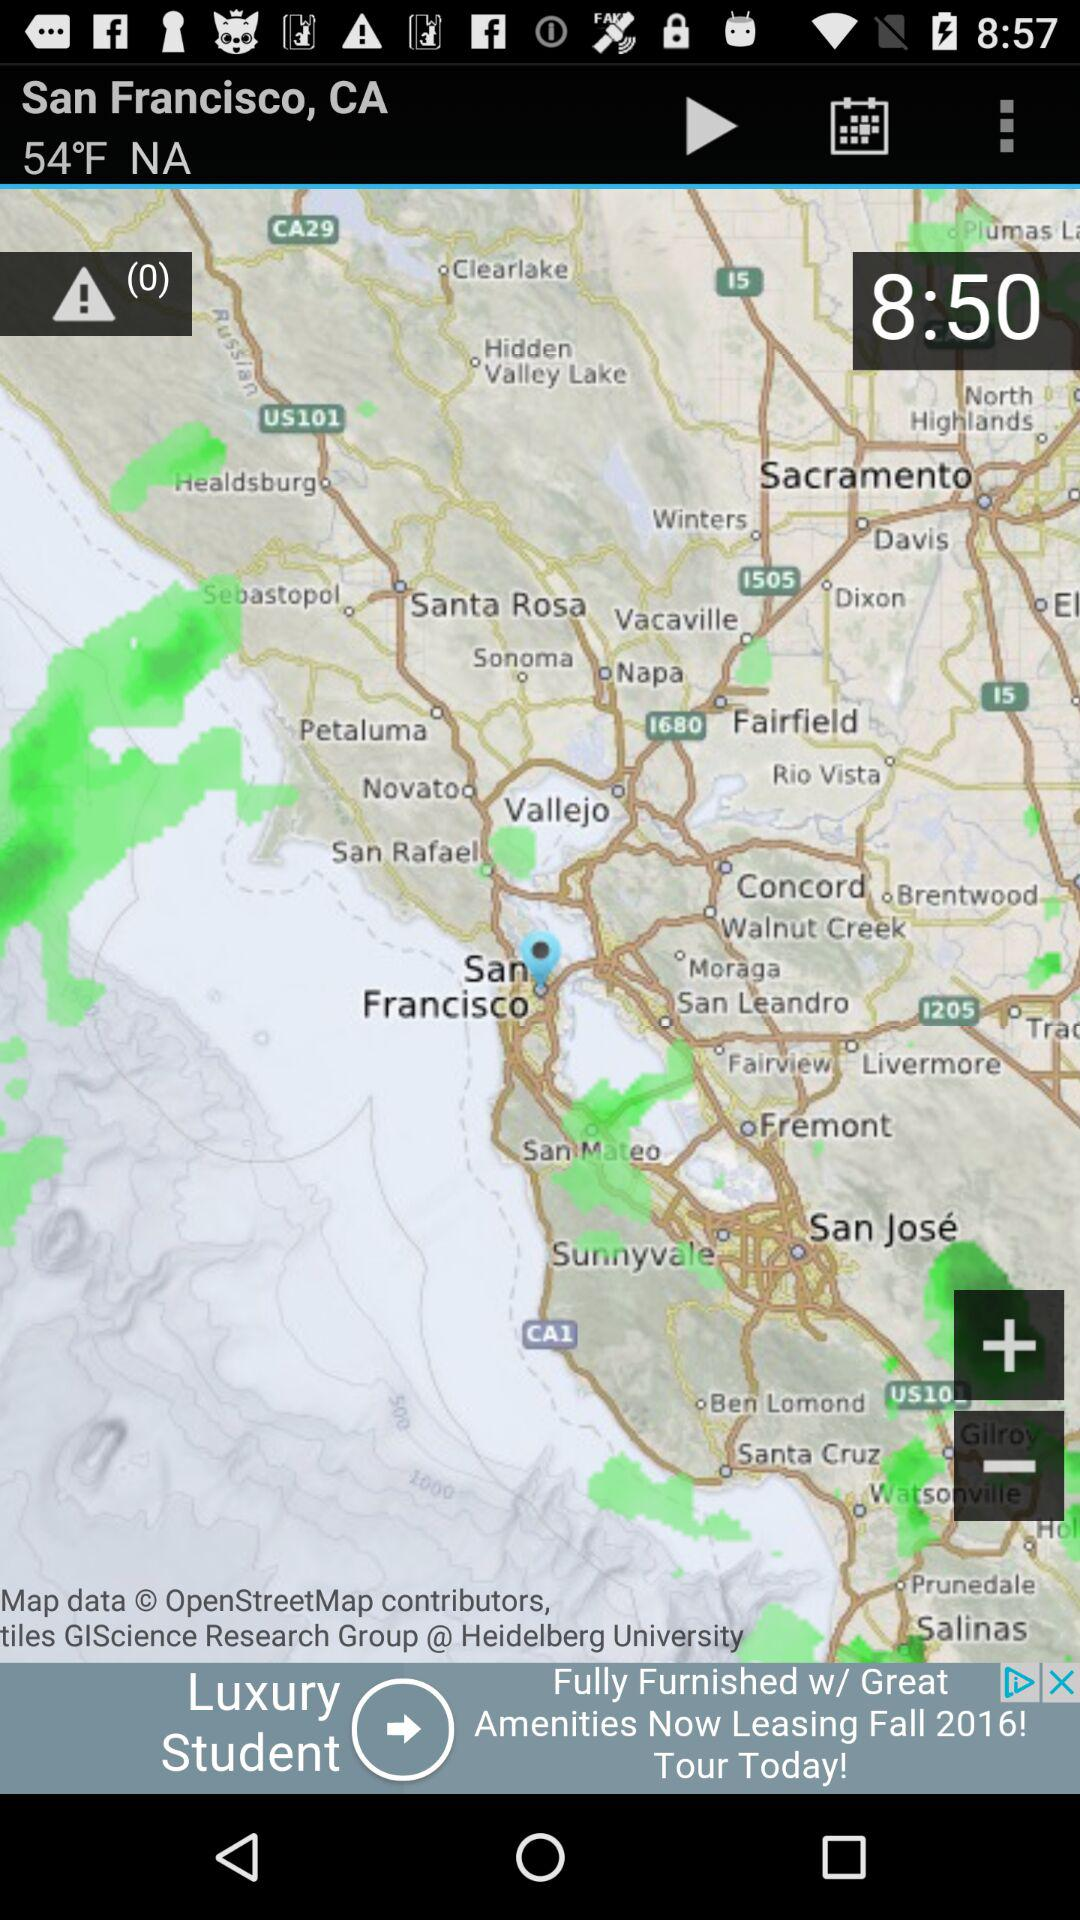What is the selected location? The selected location is San Francisco, CA. 